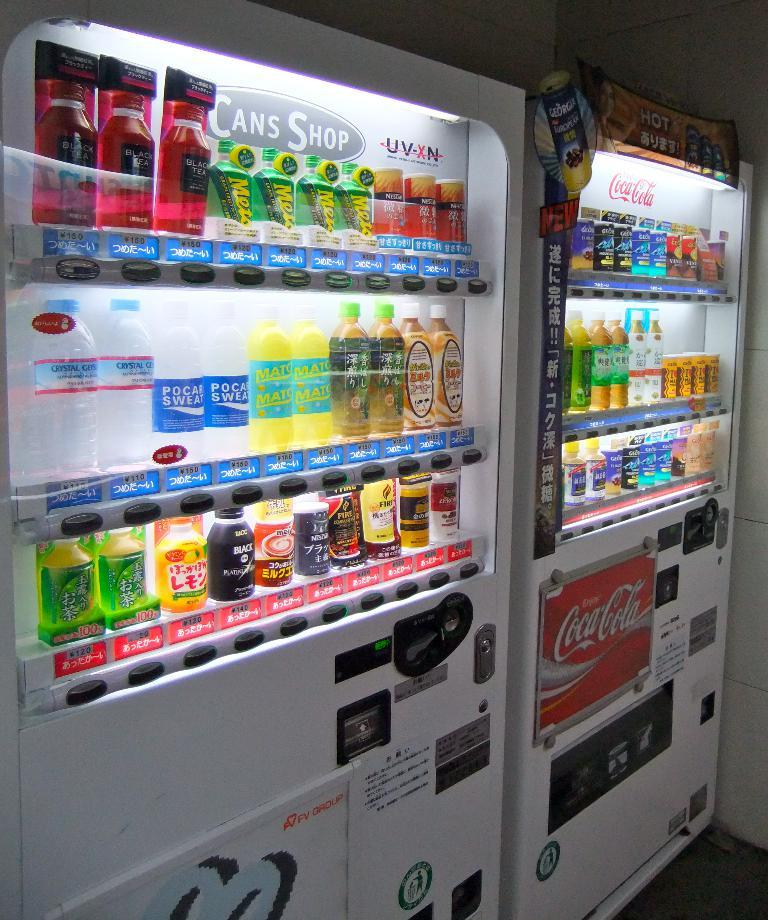<image>
Write a terse but informative summary of the picture. Coca-Cola vending machines have Black Tea and Crystal Geyser water for sale. 